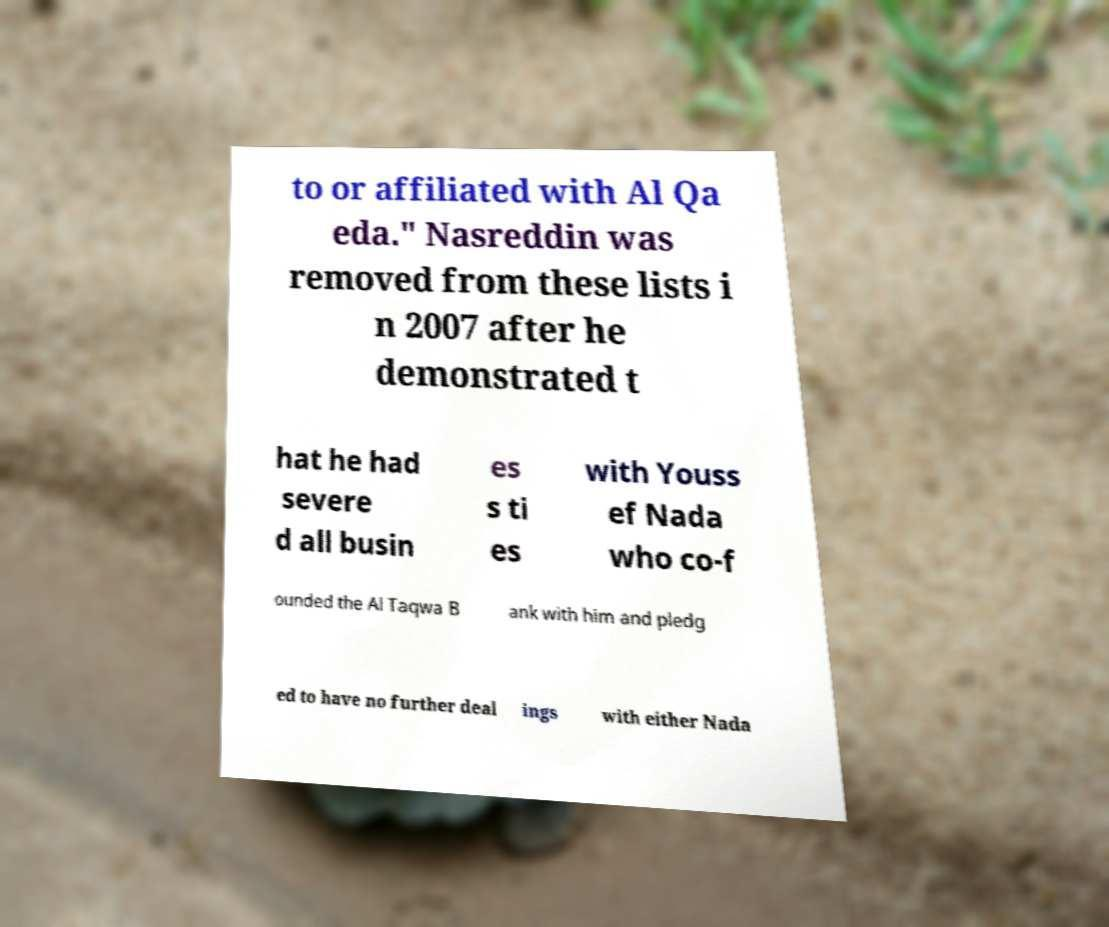Can you accurately transcribe the text from the provided image for me? to or affiliated with Al Qa eda." Nasreddin was removed from these lists i n 2007 after he demonstrated t hat he had severe d all busin es s ti es with Youss ef Nada who co-f ounded the Al Taqwa B ank with him and pledg ed to have no further deal ings with either Nada 